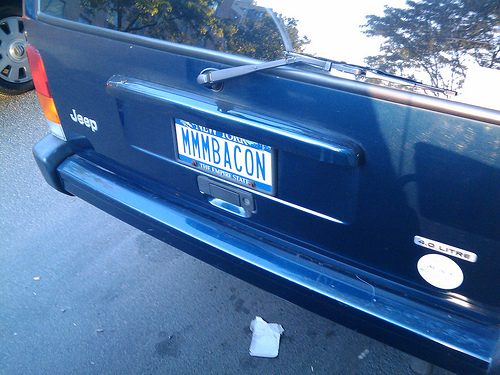<image>
Is the windshield above the wiper? Yes. The windshield is positioned above the wiper in the vertical space, higher up in the scene. Is there a license plate in front of the bumper? No. The license plate is not in front of the bumper. The spatial positioning shows a different relationship between these objects. 